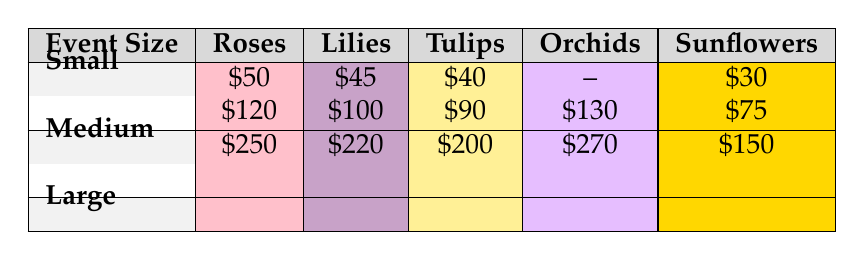What is the cost of roses for a small event? According to the table, for a small event, the cost of roses is noted as $50.
Answer: 50 What is the cost of orchids for a large event? The table shows that for a large event, the cost of orchids is $270.
Answer: 270 How much do tulips cost for a medium event? Based on the table, the cost of tulips for a medium event is $90.
Answer: 90 Is the cost of sunflowers lower than that of lilies for a small event? In the table, sunflowers cost $30 for a small event while lilies cost $45. Since $30 is less than $45, the statement is true.
Answer: Yes What is the total cost of roses and orchids for medium-sized events? From the table, the cost of roses for a medium event is $120 and for orchids, it is $130. Adding these values gives: $120 + $130 = $250.
Answer: 250 Which flower type is the most expensive for a large event? The table lists the costs for a large event: roses at $250, lilies at $220, tulips at $200, orchids at $270, and sunflowers at $150. Orchids have the highest cost of $270, making them the most expensive.
Answer: Orchids What is the average cost of flowers for small events? The costs for small events from the table are: roses at $50, lilies at $45, tulips at $40, and sunflowers at $30. To find the average, we sum the costs: $50 + $45 + $40 + $30 = $165. There are 4 flower types, so we calculate the average as $165 / 4 = $41.25.
Answer: 41.25 Are the costs of lilies the same for medium and large events? The table indicates that lilies cost $100 for medium events and $220 for large events. Since $100 does not equal $220, the statement is false.
Answer: No What is the difference in cost between tulips for small and large events? From the table, tulips cost $40 for small events and $200 for large events. To find the difference, we subtract: $200 - $40 = $160.
Answer: 160 